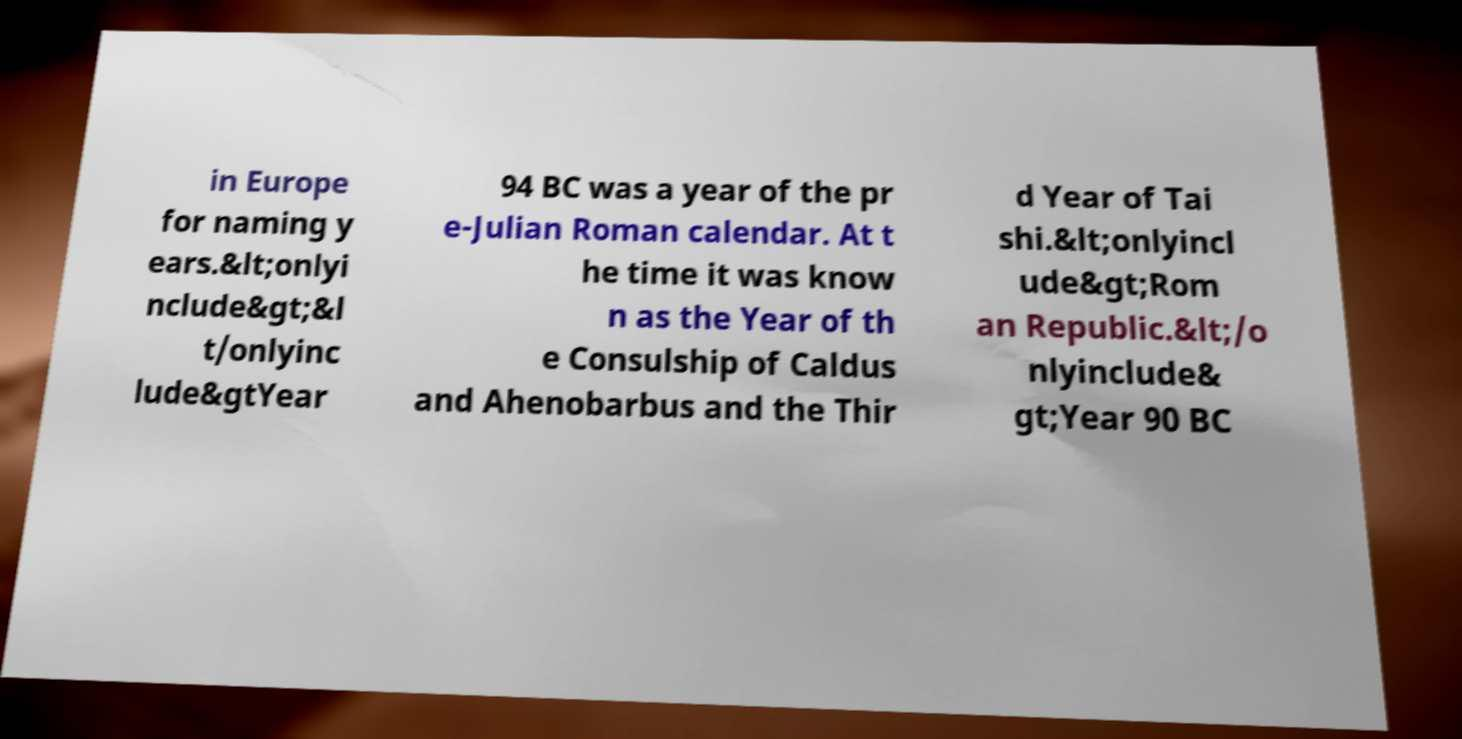Please identify and transcribe the text found in this image. in Europe for naming y ears.&lt;onlyi nclude&gt;&l t/onlyinc lude&gtYear 94 BC was a year of the pr e-Julian Roman calendar. At t he time it was know n as the Year of th e Consulship of Caldus and Ahenobarbus and the Thir d Year of Tai shi.&lt;onlyincl ude&gt;Rom an Republic.&lt;/o nlyinclude& gt;Year 90 BC 